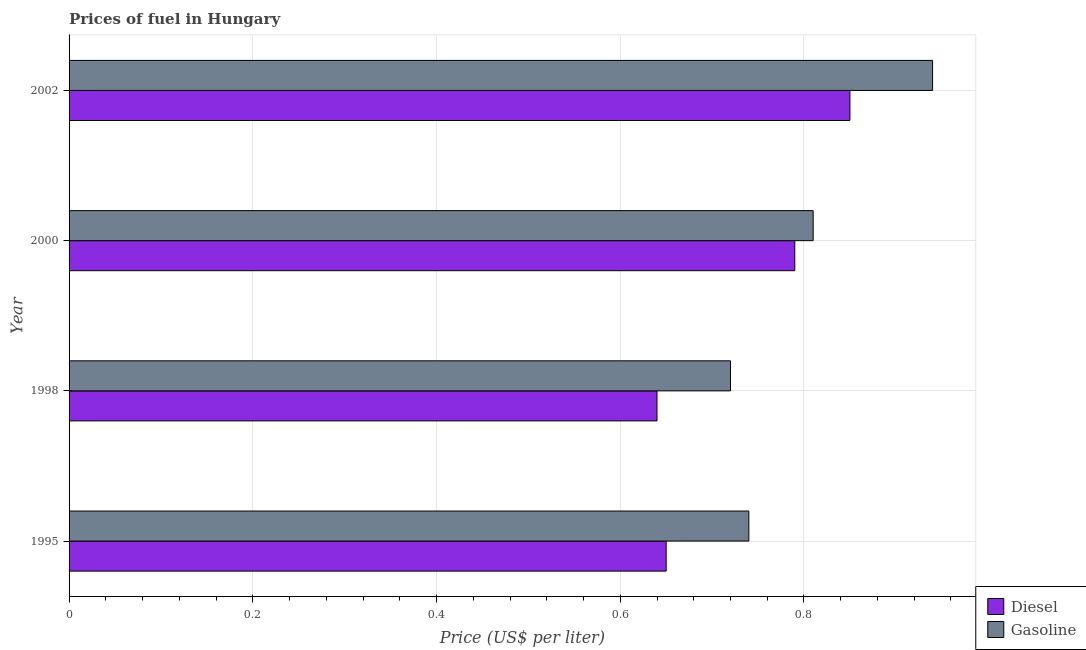How many different coloured bars are there?
Ensure brevity in your answer.  2. Are the number of bars per tick equal to the number of legend labels?
Keep it short and to the point. Yes. How many bars are there on the 1st tick from the top?
Make the answer very short. 2. What is the label of the 4th group of bars from the top?
Keep it short and to the point. 1995. What is the gasoline price in 1995?
Give a very brief answer. 0.74. Across all years, what is the maximum diesel price?
Provide a short and direct response. 0.85. Across all years, what is the minimum diesel price?
Offer a terse response. 0.64. In which year was the gasoline price minimum?
Provide a succinct answer. 1998. What is the total gasoline price in the graph?
Give a very brief answer. 3.21. What is the difference between the diesel price in 1995 and that in 2000?
Offer a terse response. -0.14. What is the difference between the gasoline price in 1998 and the diesel price in 2000?
Offer a terse response. -0.07. What is the average gasoline price per year?
Provide a succinct answer. 0.8. In the year 1995, what is the difference between the gasoline price and diesel price?
Provide a short and direct response. 0.09. In how many years, is the diesel price greater than 0.6400000000000001 US$ per litre?
Ensure brevity in your answer.  3. What is the ratio of the gasoline price in 1995 to that in 1998?
Give a very brief answer. 1.03. What is the difference between the highest and the second highest gasoline price?
Keep it short and to the point. 0.13. What is the difference between the highest and the lowest diesel price?
Provide a succinct answer. 0.21. In how many years, is the diesel price greater than the average diesel price taken over all years?
Your answer should be very brief. 2. Is the sum of the diesel price in 2000 and 2002 greater than the maximum gasoline price across all years?
Offer a very short reply. Yes. What does the 2nd bar from the top in 2000 represents?
Give a very brief answer. Diesel. What does the 2nd bar from the bottom in 1995 represents?
Offer a terse response. Gasoline. How many bars are there?
Keep it short and to the point. 8. Are all the bars in the graph horizontal?
Your response must be concise. Yes. Are the values on the major ticks of X-axis written in scientific E-notation?
Provide a short and direct response. No. Does the graph contain any zero values?
Your response must be concise. No. Does the graph contain grids?
Provide a succinct answer. Yes. How are the legend labels stacked?
Offer a terse response. Vertical. What is the title of the graph?
Offer a terse response. Prices of fuel in Hungary. Does "GDP" appear as one of the legend labels in the graph?
Your answer should be compact. No. What is the label or title of the X-axis?
Your response must be concise. Price (US$ per liter). What is the Price (US$ per liter) of Diesel in 1995?
Offer a terse response. 0.65. What is the Price (US$ per liter) of Gasoline in 1995?
Provide a short and direct response. 0.74. What is the Price (US$ per liter) in Diesel in 1998?
Ensure brevity in your answer.  0.64. What is the Price (US$ per liter) in Gasoline in 1998?
Make the answer very short. 0.72. What is the Price (US$ per liter) of Diesel in 2000?
Your answer should be compact. 0.79. What is the Price (US$ per liter) in Gasoline in 2000?
Give a very brief answer. 0.81. What is the Price (US$ per liter) in Diesel in 2002?
Your answer should be very brief. 0.85. What is the Price (US$ per liter) in Gasoline in 2002?
Keep it short and to the point. 0.94. Across all years, what is the maximum Price (US$ per liter) in Diesel?
Offer a terse response. 0.85. Across all years, what is the minimum Price (US$ per liter) in Diesel?
Your response must be concise. 0.64. Across all years, what is the minimum Price (US$ per liter) in Gasoline?
Your response must be concise. 0.72. What is the total Price (US$ per liter) in Diesel in the graph?
Your answer should be compact. 2.93. What is the total Price (US$ per liter) of Gasoline in the graph?
Give a very brief answer. 3.21. What is the difference between the Price (US$ per liter) of Diesel in 1995 and that in 1998?
Your response must be concise. 0.01. What is the difference between the Price (US$ per liter) of Diesel in 1995 and that in 2000?
Ensure brevity in your answer.  -0.14. What is the difference between the Price (US$ per liter) of Gasoline in 1995 and that in 2000?
Ensure brevity in your answer.  -0.07. What is the difference between the Price (US$ per liter) of Gasoline in 1995 and that in 2002?
Give a very brief answer. -0.2. What is the difference between the Price (US$ per liter) in Gasoline in 1998 and that in 2000?
Provide a short and direct response. -0.09. What is the difference between the Price (US$ per liter) of Diesel in 1998 and that in 2002?
Your answer should be compact. -0.21. What is the difference between the Price (US$ per liter) in Gasoline in 1998 and that in 2002?
Keep it short and to the point. -0.22. What is the difference between the Price (US$ per liter) of Diesel in 2000 and that in 2002?
Give a very brief answer. -0.06. What is the difference between the Price (US$ per liter) in Gasoline in 2000 and that in 2002?
Make the answer very short. -0.13. What is the difference between the Price (US$ per liter) in Diesel in 1995 and the Price (US$ per liter) in Gasoline in 1998?
Ensure brevity in your answer.  -0.07. What is the difference between the Price (US$ per liter) of Diesel in 1995 and the Price (US$ per liter) of Gasoline in 2000?
Ensure brevity in your answer.  -0.16. What is the difference between the Price (US$ per liter) in Diesel in 1995 and the Price (US$ per liter) in Gasoline in 2002?
Your answer should be very brief. -0.29. What is the difference between the Price (US$ per liter) in Diesel in 1998 and the Price (US$ per liter) in Gasoline in 2000?
Give a very brief answer. -0.17. What is the average Price (US$ per liter) of Diesel per year?
Your response must be concise. 0.73. What is the average Price (US$ per liter) of Gasoline per year?
Your answer should be very brief. 0.8. In the year 1995, what is the difference between the Price (US$ per liter) in Diesel and Price (US$ per liter) in Gasoline?
Make the answer very short. -0.09. In the year 1998, what is the difference between the Price (US$ per liter) in Diesel and Price (US$ per liter) in Gasoline?
Your answer should be compact. -0.08. In the year 2000, what is the difference between the Price (US$ per liter) in Diesel and Price (US$ per liter) in Gasoline?
Your response must be concise. -0.02. In the year 2002, what is the difference between the Price (US$ per liter) in Diesel and Price (US$ per liter) in Gasoline?
Offer a very short reply. -0.09. What is the ratio of the Price (US$ per liter) in Diesel in 1995 to that in 1998?
Provide a short and direct response. 1.02. What is the ratio of the Price (US$ per liter) in Gasoline in 1995 to that in 1998?
Offer a very short reply. 1.03. What is the ratio of the Price (US$ per liter) of Diesel in 1995 to that in 2000?
Offer a very short reply. 0.82. What is the ratio of the Price (US$ per liter) in Gasoline in 1995 to that in 2000?
Make the answer very short. 0.91. What is the ratio of the Price (US$ per liter) in Diesel in 1995 to that in 2002?
Your response must be concise. 0.76. What is the ratio of the Price (US$ per liter) in Gasoline in 1995 to that in 2002?
Ensure brevity in your answer.  0.79. What is the ratio of the Price (US$ per liter) of Diesel in 1998 to that in 2000?
Ensure brevity in your answer.  0.81. What is the ratio of the Price (US$ per liter) in Diesel in 1998 to that in 2002?
Give a very brief answer. 0.75. What is the ratio of the Price (US$ per liter) in Gasoline in 1998 to that in 2002?
Give a very brief answer. 0.77. What is the ratio of the Price (US$ per liter) of Diesel in 2000 to that in 2002?
Provide a succinct answer. 0.93. What is the ratio of the Price (US$ per liter) in Gasoline in 2000 to that in 2002?
Your answer should be compact. 0.86. What is the difference between the highest and the second highest Price (US$ per liter) of Diesel?
Offer a very short reply. 0.06. What is the difference between the highest and the second highest Price (US$ per liter) of Gasoline?
Your answer should be very brief. 0.13. What is the difference between the highest and the lowest Price (US$ per liter) in Diesel?
Give a very brief answer. 0.21. What is the difference between the highest and the lowest Price (US$ per liter) of Gasoline?
Your answer should be very brief. 0.22. 